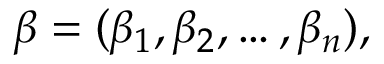Convert formula to latex. <formula><loc_0><loc_0><loc_500><loc_500>{ \beta } = ( \beta _ { 1 } , \beta _ { 2 } , \dots , \beta _ { n } ) ,</formula> 